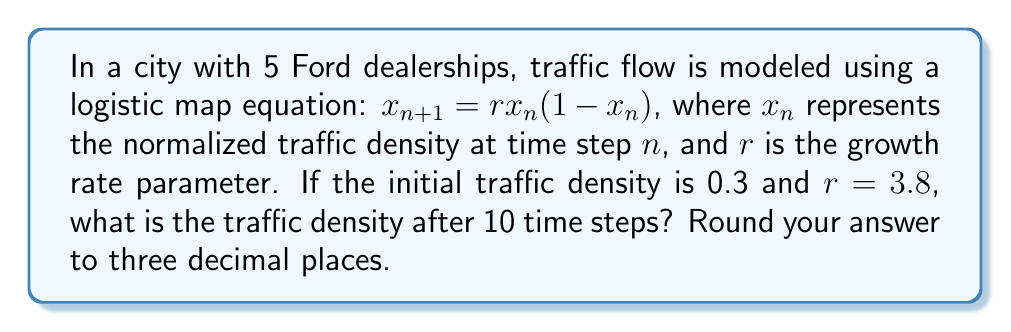Show me your answer to this math problem. To solve this problem, we'll use the logistic map equation iteratively:

1) Start with the given information:
   $x_0 = 0.3$ (initial traffic density)
   $r = 3.8$ (growth rate parameter)

2) Apply the logistic map equation for each time step:
   $x_{n+1} = rx_n(1-x_n)$

3) Calculate for 10 time steps:

   Step 1: $x_1 = 3.8 * 0.3 * (1-0.3) = 0.798$
   Step 2: $x_2 = 3.8 * 0.798 * (1-0.798) = 0.614$
   Step 3: $x_3 = 3.8 * 0.614 * (1-0.614) = 0.901$
   Step 4: $x_4 = 3.8 * 0.901 * (1-0.901) = 0.339$
   Step 5: $x_5 = 3.8 * 0.339 * (1-0.339) = 0.851$
   Step 6: $x_6 = 3.8 * 0.851 * (1-0.851) = 0.482$
   Step 7: $x_7 = 3.8 * 0.482 * (1-0.482) = 0.950$
   Step 8: $x_8 = 3.8 * 0.950 * (1-0.950) = 0.180$
   Step 9: $x_9 = 3.8 * 0.180 * (1-0.180) = 0.562$
   Step 10: $x_{10} = 3.8 * 0.562 * (1-0.562) = 0.935$

4) Round the final result to three decimal places: 0.935
Answer: 0.935 